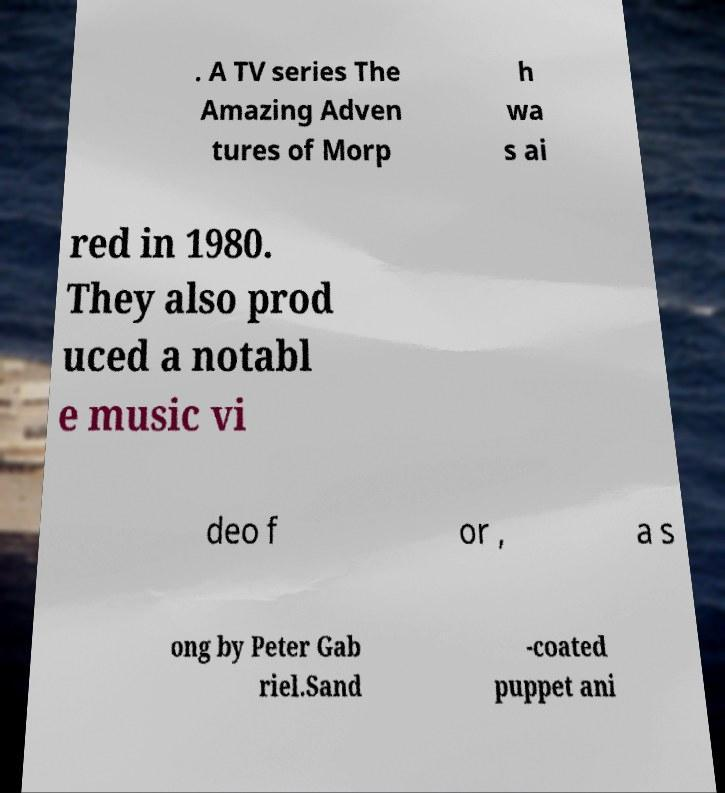What messages or text are displayed in this image? I need them in a readable, typed format. . A TV series The Amazing Adven tures of Morp h wa s ai red in 1980. They also prod uced a notabl e music vi deo f or , a s ong by Peter Gab riel.Sand -coated puppet ani 